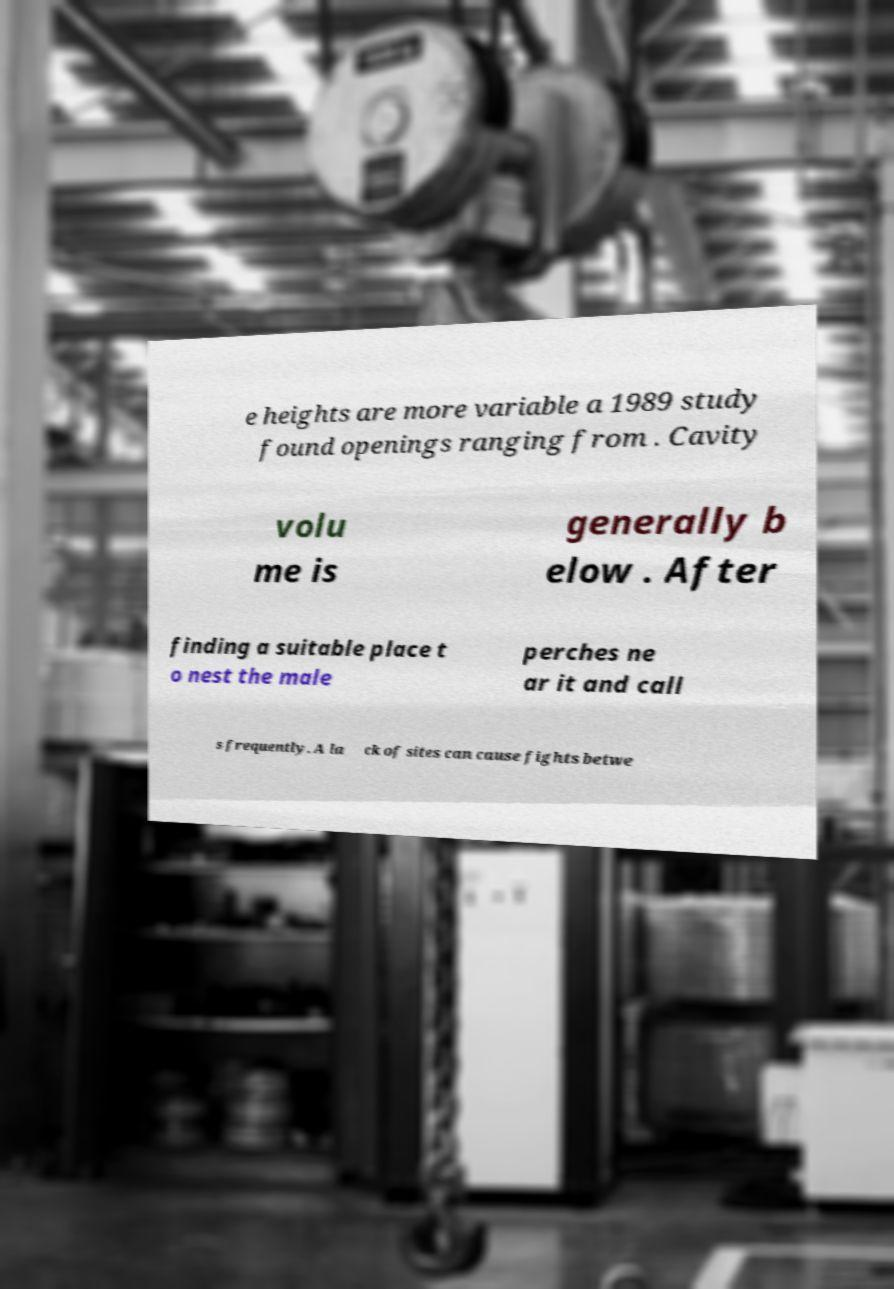Could you assist in decoding the text presented in this image and type it out clearly? e heights are more variable a 1989 study found openings ranging from . Cavity volu me is generally b elow . After finding a suitable place t o nest the male perches ne ar it and call s frequently. A la ck of sites can cause fights betwe 